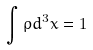<formula> <loc_0><loc_0><loc_500><loc_500>\int \rho d ^ { 3 } x = 1</formula> 